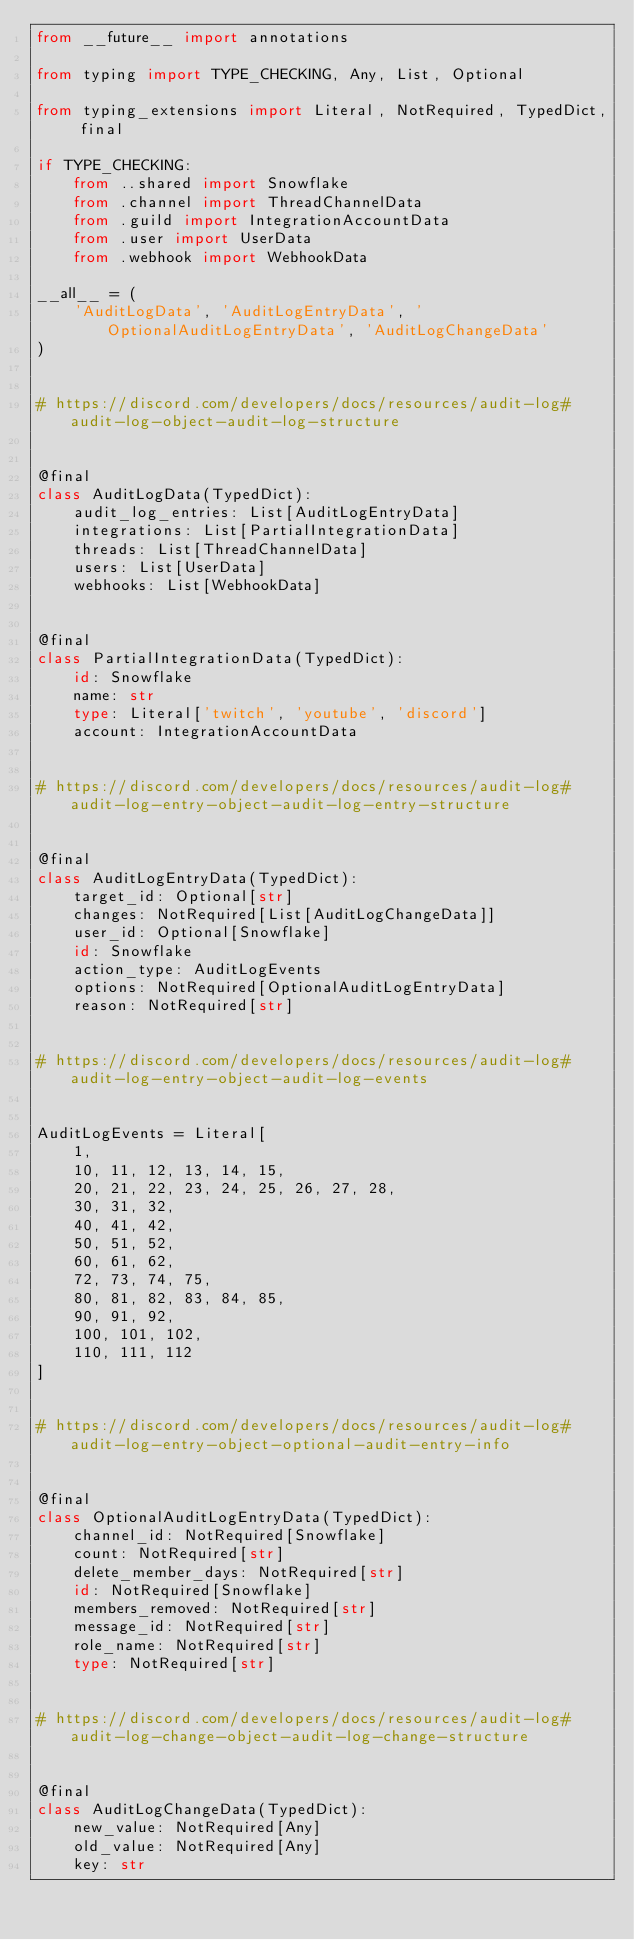Convert code to text. <code><loc_0><loc_0><loc_500><loc_500><_Python_>from __future__ import annotations

from typing import TYPE_CHECKING, Any, List, Optional

from typing_extensions import Literal, NotRequired, TypedDict, final

if TYPE_CHECKING:
    from ..shared import Snowflake
    from .channel import ThreadChannelData
    from .guild import IntegrationAccountData
    from .user import UserData
    from .webhook import WebhookData

__all__ = (
    'AuditLogData', 'AuditLogEntryData', 'OptionalAuditLogEntryData', 'AuditLogChangeData'
)


# https://discord.com/developers/docs/resources/audit-log#audit-log-object-audit-log-structure


@final
class AuditLogData(TypedDict):
    audit_log_entries: List[AuditLogEntryData]
    integrations: List[PartialIntegrationData]
    threads: List[ThreadChannelData]
    users: List[UserData]
    webhooks: List[WebhookData]


@final
class PartialIntegrationData(TypedDict):
    id: Snowflake
    name: str
    type: Literal['twitch', 'youtube', 'discord']
    account: IntegrationAccountData


# https://discord.com/developers/docs/resources/audit-log#audit-log-entry-object-audit-log-entry-structure


@final
class AuditLogEntryData(TypedDict):
    target_id: Optional[str]
    changes: NotRequired[List[AuditLogChangeData]]
    user_id: Optional[Snowflake]
    id: Snowflake
    action_type: AuditLogEvents
    options: NotRequired[OptionalAuditLogEntryData]
    reason: NotRequired[str]


# https://discord.com/developers/docs/resources/audit-log#audit-log-entry-object-audit-log-events


AuditLogEvents = Literal[
    1,
    10, 11, 12, 13, 14, 15,
    20, 21, 22, 23, 24, 25, 26, 27, 28,
    30, 31, 32,
    40, 41, 42,
    50, 51, 52,
    60, 61, 62,
    72, 73, 74, 75,
    80, 81, 82, 83, 84, 85,
    90, 91, 92,
    100, 101, 102,
    110, 111, 112
]


# https://discord.com/developers/docs/resources/audit-log#audit-log-entry-object-optional-audit-entry-info


@final
class OptionalAuditLogEntryData(TypedDict):
    channel_id: NotRequired[Snowflake]
    count: NotRequired[str]
    delete_member_days: NotRequired[str]
    id: NotRequired[Snowflake]
    members_removed: NotRequired[str]
    message_id: NotRequired[str]
    role_name: NotRequired[str]
    type: NotRequired[str]


# https://discord.com/developers/docs/resources/audit-log#audit-log-change-object-audit-log-change-structure


@final
class AuditLogChangeData(TypedDict):
    new_value: NotRequired[Any]
    old_value: NotRequired[Any]
    key: str
</code> 